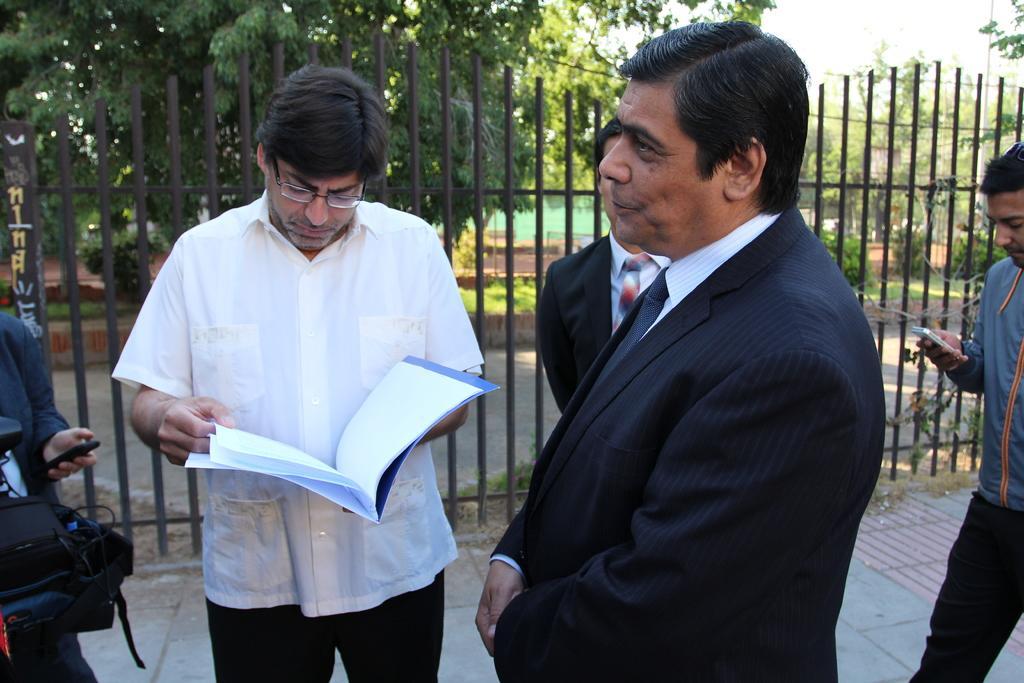How would you summarize this image in a sentence or two? In this picture we can see a man is holding a file and he is looking into the papers beside some people are standing they are talking to each other few people are holding mobiles at background we can see grass and trees. 